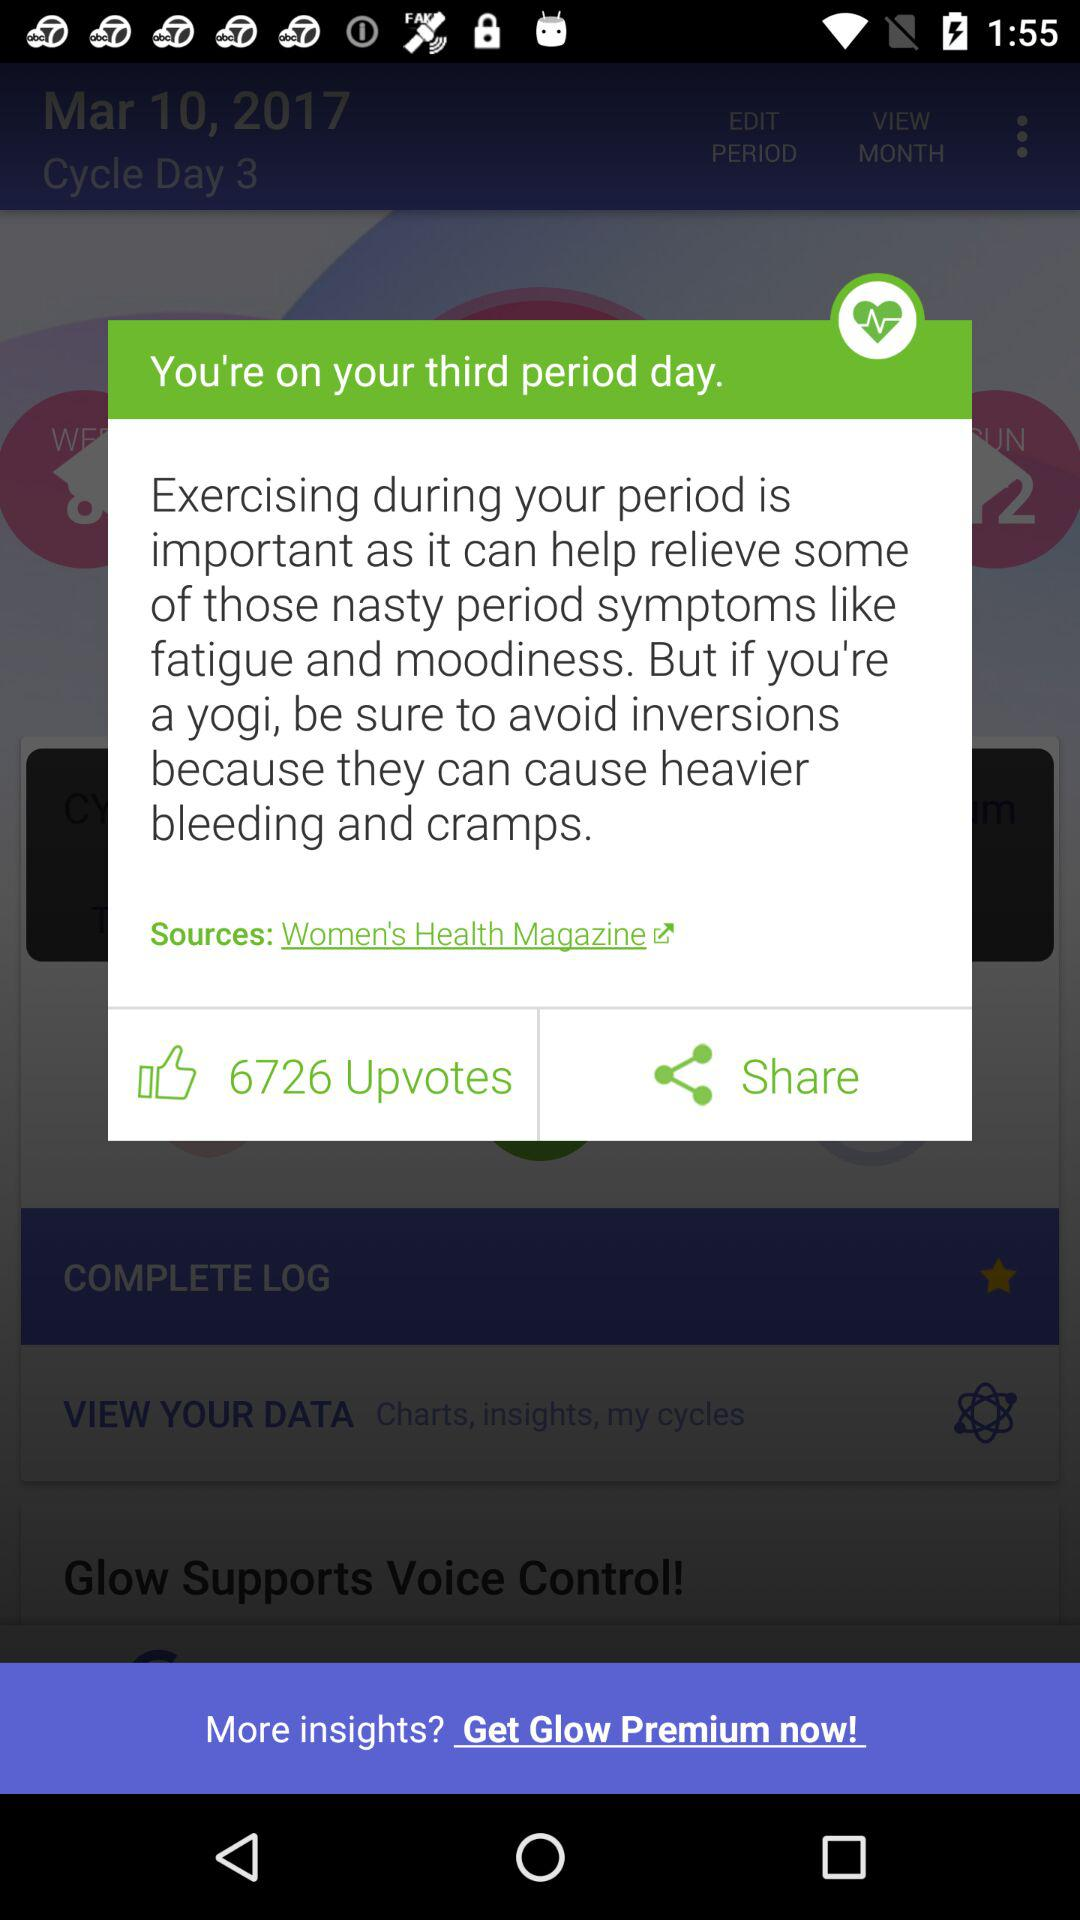How many more upvotes does the article have than shares?
Answer the question using a single word or phrase. 6726 